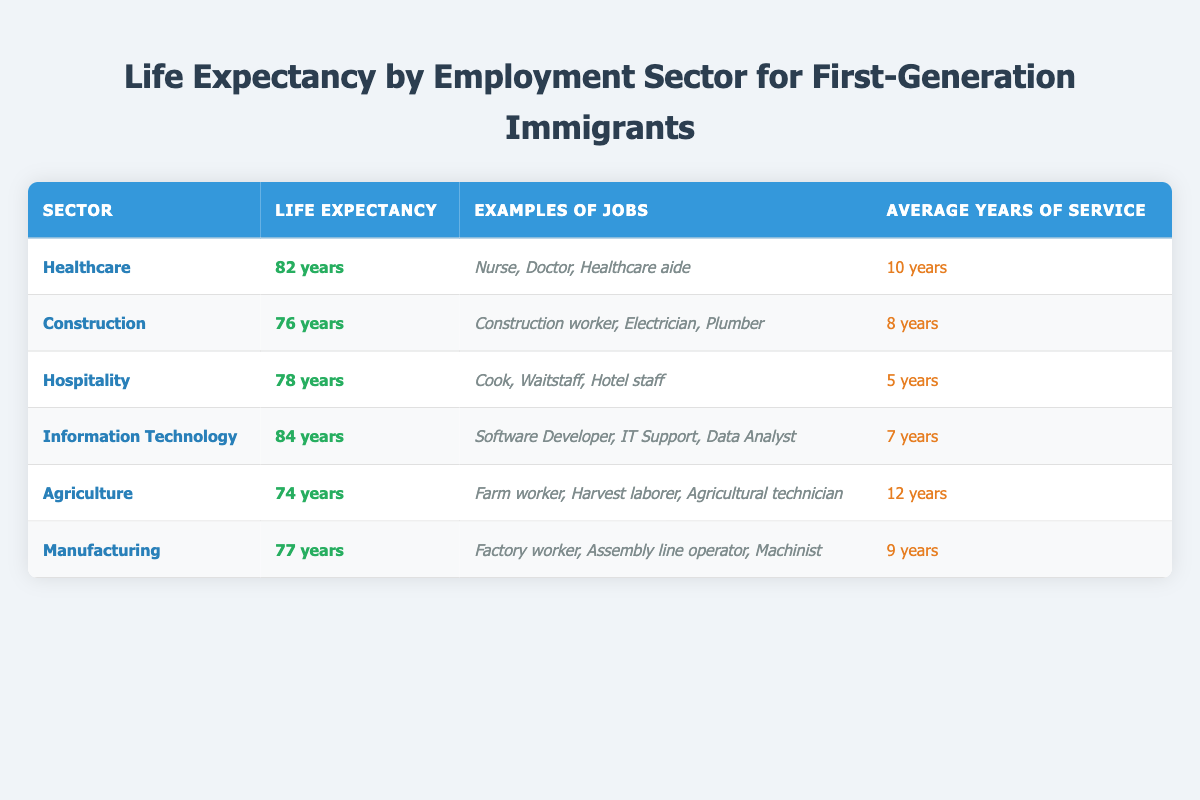What is the life expectancy for first-generation immigrants working in the Information Technology sector? The table lists the life expectancy for each employment sector. In the Information Technology sector, the life expectancy is stated as 84 years.
Answer: 84 years Which employment sector has the lowest life expectancy? Upon reviewing the table, the Agriculture sector shows the lowest life expectancy at 74 years.
Answer: Agriculture What is the average life expectancy for first-generation immigrants working in Healthcare and Hospitality? The life expectancy in Healthcare is 82 years and in Hospitality is 78 years. Adding these gives 82 + 78 = 160 years. To find the average, divide by 2, resulting in 160 / 2 = 80 years.
Answer: 80 years Is the average years of service for workers in Construction more than for those in Manufacturing? The average years of service in Construction is 8 years, while in Manufacturing it is 9 years. Since 8 is not greater than 9, the answer is no.
Answer: No What are the average life expectancies for the sectors that have an average of 10 years or more of service? The sectors with 10 or more years of service are Healthcare (82 years), Agriculture (74 years), and Manufacturing (77 years). Summing these gives 82 + 74 + 77 = 233 years. The average is then 233 / 3 ≈ 77.67 years.
Answer: Approximately 77.67 years Which sector has examples of jobs including Cooks and Waitstaff? According to the table, the Hospitality sector lists Cooks and Waitstaff as examples of jobs.
Answer: Hospitality What is the difference in life expectancy between the Information Technology and Agriculture sectors? The life expectancy for Information Technology is 84 years and for Agriculture it is 74 years. The difference can be calculated by subtracting, which gives 84 - 74 = 10 years.
Answer: 10 years In which sector do workers serve for an average of only 5 years? The table indicates that the Hospitality sector has an average of 5 years of service.
Answer: Hospitality 